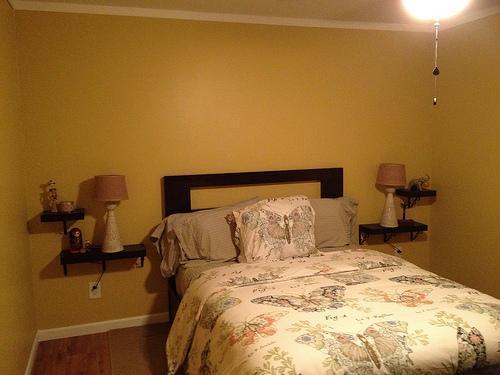How many people can fit in the bed?
Give a very brief answer. 2. How many lamps are there?
Give a very brief answer. 2. 